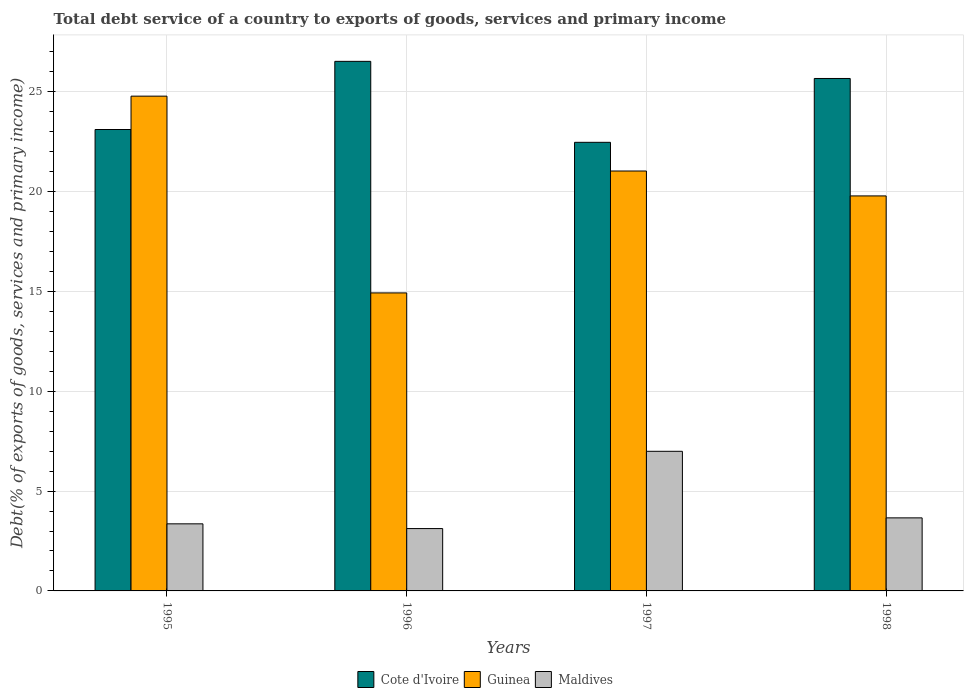In how many cases, is the number of bars for a given year not equal to the number of legend labels?
Offer a terse response. 0. What is the total debt service in Maldives in 1997?
Provide a succinct answer. 6.99. Across all years, what is the maximum total debt service in Cote d'Ivoire?
Offer a very short reply. 26.53. Across all years, what is the minimum total debt service in Cote d'Ivoire?
Keep it short and to the point. 22.47. What is the total total debt service in Cote d'Ivoire in the graph?
Keep it short and to the point. 97.78. What is the difference between the total debt service in Guinea in 1997 and that in 1998?
Provide a short and direct response. 1.25. What is the difference between the total debt service in Guinea in 1997 and the total debt service in Cote d'Ivoire in 1996?
Your response must be concise. -5.49. What is the average total debt service in Guinea per year?
Your answer should be very brief. 20.13. In the year 1998, what is the difference between the total debt service in Maldives and total debt service in Cote d'Ivoire?
Offer a very short reply. -22.01. In how many years, is the total debt service in Cote d'Ivoire greater than 26 %?
Give a very brief answer. 1. What is the ratio of the total debt service in Cote d'Ivoire in 1995 to that in 1998?
Give a very brief answer. 0.9. Is the difference between the total debt service in Maldives in 1995 and 1998 greater than the difference between the total debt service in Cote d'Ivoire in 1995 and 1998?
Your answer should be compact. Yes. What is the difference between the highest and the second highest total debt service in Cote d'Ivoire?
Keep it short and to the point. 0.86. What is the difference between the highest and the lowest total debt service in Guinea?
Ensure brevity in your answer.  9.86. What does the 1st bar from the left in 1998 represents?
Offer a very short reply. Cote d'Ivoire. What does the 3rd bar from the right in 1996 represents?
Keep it short and to the point. Cote d'Ivoire. Is it the case that in every year, the sum of the total debt service in Maldives and total debt service in Cote d'Ivoire is greater than the total debt service in Guinea?
Offer a terse response. Yes. How many bars are there?
Your response must be concise. 12. Are all the bars in the graph horizontal?
Your response must be concise. No. How many years are there in the graph?
Offer a very short reply. 4. Does the graph contain any zero values?
Provide a short and direct response. No. Where does the legend appear in the graph?
Give a very brief answer. Bottom center. How many legend labels are there?
Ensure brevity in your answer.  3. What is the title of the graph?
Keep it short and to the point. Total debt service of a country to exports of goods, services and primary income. What is the label or title of the X-axis?
Offer a terse response. Years. What is the label or title of the Y-axis?
Offer a terse response. Debt(% of exports of goods, services and primary income). What is the Debt(% of exports of goods, services and primary income) of Cote d'Ivoire in 1995?
Give a very brief answer. 23.11. What is the Debt(% of exports of goods, services and primary income) of Guinea in 1995?
Your answer should be very brief. 24.78. What is the Debt(% of exports of goods, services and primary income) in Maldives in 1995?
Ensure brevity in your answer.  3.36. What is the Debt(% of exports of goods, services and primary income) in Cote d'Ivoire in 1996?
Provide a succinct answer. 26.53. What is the Debt(% of exports of goods, services and primary income) in Guinea in 1996?
Keep it short and to the point. 14.93. What is the Debt(% of exports of goods, services and primary income) in Maldives in 1996?
Ensure brevity in your answer.  3.12. What is the Debt(% of exports of goods, services and primary income) of Cote d'Ivoire in 1997?
Your response must be concise. 22.47. What is the Debt(% of exports of goods, services and primary income) in Guinea in 1997?
Your response must be concise. 21.03. What is the Debt(% of exports of goods, services and primary income) of Maldives in 1997?
Keep it short and to the point. 6.99. What is the Debt(% of exports of goods, services and primary income) in Cote d'Ivoire in 1998?
Make the answer very short. 25.67. What is the Debt(% of exports of goods, services and primary income) in Guinea in 1998?
Your answer should be compact. 19.79. What is the Debt(% of exports of goods, services and primary income) of Maldives in 1998?
Offer a very short reply. 3.66. Across all years, what is the maximum Debt(% of exports of goods, services and primary income) of Cote d'Ivoire?
Make the answer very short. 26.53. Across all years, what is the maximum Debt(% of exports of goods, services and primary income) in Guinea?
Provide a short and direct response. 24.78. Across all years, what is the maximum Debt(% of exports of goods, services and primary income) of Maldives?
Your response must be concise. 6.99. Across all years, what is the minimum Debt(% of exports of goods, services and primary income) in Cote d'Ivoire?
Offer a very short reply. 22.47. Across all years, what is the minimum Debt(% of exports of goods, services and primary income) of Guinea?
Your answer should be very brief. 14.93. Across all years, what is the minimum Debt(% of exports of goods, services and primary income) of Maldives?
Offer a terse response. 3.12. What is the total Debt(% of exports of goods, services and primary income) in Cote d'Ivoire in the graph?
Keep it short and to the point. 97.78. What is the total Debt(% of exports of goods, services and primary income) of Guinea in the graph?
Your answer should be very brief. 80.53. What is the total Debt(% of exports of goods, services and primary income) of Maldives in the graph?
Your answer should be very brief. 17.14. What is the difference between the Debt(% of exports of goods, services and primary income) of Cote d'Ivoire in 1995 and that in 1996?
Keep it short and to the point. -3.41. What is the difference between the Debt(% of exports of goods, services and primary income) of Guinea in 1995 and that in 1996?
Provide a short and direct response. 9.86. What is the difference between the Debt(% of exports of goods, services and primary income) of Maldives in 1995 and that in 1996?
Your response must be concise. 0.24. What is the difference between the Debt(% of exports of goods, services and primary income) in Cote d'Ivoire in 1995 and that in 1997?
Provide a succinct answer. 0.64. What is the difference between the Debt(% of exports of goods, services and primary income) in Guinea in 1995 and that in 1997?
Make the answer very short. 3.75. What is the difference between the Debt(% of exports of goods, services and primary income) in Maldives in 1995 and that in 1997?
Keep it short and to the point. -3.63. What is the difference between the Debt(% of exports of goods, services and primary income) of Cote d'Ivoire in 1995 and that in 1998?
Your response must be concise. -2.56. What is the difference between the Debt(% of exports of goods, services and primary income) of Guinea in 1995 and that in 1998?
Keep it short and to the point. 5. What is the difference between the Debt(% of exports of goods, services and primary income) in Maldives in 1995 and that in 1998?
Ensure brevity in your answer.  -0.3. What is the difference between the Debt(% of exports of goods, services and primary income) in Cote d'Ivoire in 1996 and that in 1997?
Provide a short and direct response. 4.06. What is the difference between the Debt(% of exports of goods, services and primary income) in Guinea in 1996 and that in 1997?
Provide a succinct answer. -6.11. What is the difference between the Debt(% of exports of goods, services and primary income) of Maldives in 1996 and that in 1997?
Your response must be concise. -3.87. What is the difference between the Debt(% of exports of goods, services and primary income) of Cote d'Ivoire in 1996 and that in 1998?
Make the answer very short. 0.86. What is the difference between the Debt(% of exports of goods, services and primary income) of Guinea in 1996 and that in 1998?
Offer a very short reply. -4.86. What is the difference between the Debt(% of exports of goods, services and primary income) of Maldives in 1996 and that in 1998?
Provide a succinct answer. -0.54. What is the difference between the Debt(% of exports of goods, services and primary income) in Cote d'Ivoire in 1997 and that in 1998?
Offer a very short reply. -3.2. What is the difference between the Debt(% of exports of goods, services and primary income) in Guinea in 1997 and that in 1998?
Offer a terse response. 1.25. What is the difference between the Debt(% of exports of goods, services and primary income) in Maldives in 1997 and that in 1998?
Your answer should be compact. 3.33. What is the difference between the Debt(% of exports of goods, services and primary income) in Cote d'Ivoire in 1995 and the Debt(% of exports of goods, services and primary income) in Guinea in 1996?
Your response must be concise. 8.18. What is the difference between the Debt(% of exports of goods, services and primary income) of Cote d'Ivoire in 1995 and the Debt(% of exports of goods, services and primary income) of Maldives in 1996?
Offer a terse response. 19.99. What is the difference between the Debt(% of exports of goods, services and primary income) in Guinea in 1995 and the Debt(% of exports of goods, services and primary income) in Maldives in 1996?
Your answer should be very brief. 21.66. What is the difference between the Debt(% of exports of goods, services and primary income) in Cote d'Ivoire in 1995 and the Debt(% of exports of goods, services and primary income) in Guinea in 1997?
Your answer should be very brief. 2.08. What is the difference between the Debt(% of exports of goods, services and primary income) of Cote d'Ivoire in 1995 and the Debt(% of exports of goods, services and primary income) of Maldives in 1997?
Provide a short and direct response. 16.12. What is the difference between the Debt(% of exports of goods, services and primary income) in Guinea in 1995 and the Debt(% of exports of goods, services and primary income) in Maldives in 1997?
Your answer should be compact. 17.79. What is the difference between the Debt(% of exports of goods, services and primary income) in Cote d'Ivoire in 1995 and the Debt(% of exports of goods, services and primary income) in Guinea in 1998?
Your answer should be very brief. 3.33. What is the difference between the Debt(% of exports of goods, services and primary income) of Cote d'Ivoire in 1995 and the Debt(% of exports of goods, services and primary income) of Maldives in 1998?
Ensure brevity in your answer.  19.45. What is the difference between the Debt(% of exports of goods, services and primary income) of Guinea in 1995 and the Debt(% of exports of goods, services and primary income) of Maldives in 1998?
Offer a very short reply. 21.12. What is the difference between the Debt(% of exports of goods, services and primary income) of Cote d'Ivoire in 1996 and the Debt(% of exports of goods, services and primary income) of Guinea in 1997?
Offer a very short reply. 5.49. What is the difference between the Debt(% of exports of goods, services and primary income) of Cote d'Ivoire in 1996 and the Debt(% of exports of goods, services and primary income) of Maldives in 1997?
Provide a short and direct response. 19.53. What is the difference between the Debt(% of exports of goods, services and primary income) in Guinea in 1996 and the Debt(% of exports of goods, services and primary income) in Maldives in 1997?
Ensure brevity in your answer.  7.93. What is the difference between the Debt(% of exports of goods, services and primary income) of Cote d'Ivoire in 1996 and the Debt(% of exports of goods, services and primary income) of Guinea in 1998?
Provide a short and direct response. 6.74. What is the difference between the Debt(% of exports of goods, services and primary income) of Cote d'Ivoire in 1996 and the Debt(% of exports of goods, services and primary income) of Maldives in 1998?
Keep it short and to the point. 22.87. What is the difference between the Debt(% of exports of goods, services and primary income) of Guinea in 1996 and the Debt(% of exports of goods, services and primary income) of Maldives in 1998?
Give a very brief answer. 11.27. What is the difference between the Debt(% of exports of goods, services and primary income) of Cote d'Ivoire in 1997 and the Debt(% of exports of goods, services and primary income) of Guinea in 1998?
Make the answer very short. 2.69. What is the difference between the Debt(% of exports of goods, services and primary income) in Cote d'Ivoire in 1997 and the Debt(% of exports of goods, services and primary income) in Maldives in 1998?
Keep it short and to the point. 18.81. What is the difference between the Debt(% of exports of goods, services and primary income) of Guinea in 1997 and the Debt(% of exports of goods, services and primary income) of Maldives in 1998?
Your response must be concise. 17.37. What is the average Debt(% of exports of goods, services and primary income) in Cote d'Ivoire per year?
Make the answer very short. 24.44. What is the average Debt(% of exports of goods, services and primary income) of Guinea per year?
Offer a terse response. 20.13. What is the average Debt(% of exports of goods, services and primary income) of Maldives per year?
Offer a very short reply. 4.28. In the year 1995, what is the difference between the Debt(% of exports of goods, services and primary income) in Cote d'Ivoire and Debt(% of exports of goods, services and primary income) in Guinea?
Your answer should be compact. -1.67. In the year 1995, what is the difference between the Debt(% of exports of goods, services and primary income) of Cote d'Ivoire and Debt(% of exports of goods, services and primary income) of Maldives?
Keep it short and to the point. 19.75. In the year 1995, what is the difference between the Debt(% of exports of goods, services and primary income) of Guinea and Debt(% of exports of goods, services and primary income) of Maldives?
Keep it short and to the point. 21.42. In the year 1996, what is the difference between the Debt(% of exports of goods, services and primary income) of Cote d'Ivoire and Debt(% of exports of goods, services and primary income) of Guinea?
Your response must be concise. 11.6. In the year 1996, what is the difference between the Debt(% of exports of goods, services and primary income) in Cote d'Ivoire and Debt(% of exports of goods, services and primary income) in Maldives?
Make the answer very short. 23.4. In the year 1996, what is the difference between the Debt(% of exports of goods, services and primary income) of Guinea and Debt(% of exports of goods, services and primary income) of Maldives?
Your response must be concise. 11.8. In the year 1997, what is the difference between the Debt(% of exports of goods, services and primary income) in Cote d'Ivoire and Debt(% of exports of goods, services and primary income) in Guinea?
Make the answer very short. 1.44. In the year 1997, what is the difference between the Debt(% of exports of goods, services and primary income) of Cote d'Ivoire and Debt(% of exports of goods, services and primary income) of Maldives?
Your response must be concise. 15.48. In the year 1997, what is the difference between the Debt(% of exports of goods, services and primary income) in Guinea and Debt(% of exports of goods, services and primary income) in Maldives?
Provide a succinct answer. 14.04. In the year 1998, what is the difference between the Debt(% of exports of goods, services and primary income) in Cote d'Ivoire and Debt(% of exports of goods, services and primary income) in Guinea?
Make the answer very short. 5.88. In the year 1998, what is the difference between the Debt(% of exports of goods, services and primary income) of Cote d'Ivoire and Debt(% of exports of goods, services and primary income) of Maldives?
Keep it short and to the point. 22.01. In the year 1998, what is the difference between the Debt(% of exports of goods, services and primary income) of Guinea and Debt(% of exports of goods, services and primary income) of Maldives?
Keep it short and to the point. 16.13. What is the ratio of the Debt(% of exports of goods, services and primary income) in Cote d'Ivoire in 1995 to that in 1996?
Provide a succinct answer. 0.87. What is the ratio of the Debt(% of exports of goods, services and primary income) in Guinea in 1995 to that in 1996?
Make the answer very short. 1.66. What is the ratio of the Debt(% of exports of goods, services and primary income) of Maldives in 1995 to that in 1996?
Your answer should be compact. 1.08. What is the ratio of the Debt(% of exports of goods, services and primary income) of Cote d'Ivoire in 1995 to that in 1997?
Give a very brief answer. 1.03. What is the ratio of the Debt(% of exports of goods, services and primary income) in Guinea in 1995 to that in 1997?
Offer a very short reply. 1.18. What is the ratio of the Debt(% of exports of goods, services and primary income) in Maldives in 1995 to that in 1997?
Make the answer very short. 0.48. What is the ratio of the Debt(% of exports of goods, services and primary income) of Cote d'Ivoire in 1995 to that in 1998?
Give a very brief answer. 0.9. What is the ratio of the Debt(% of exports of goods, services and primary income) of Guinea in 1995 to that in 1998?
Your answer should be very brief. 1.25. What is the ratio of the Debt(% of exports of goods, services and primary income) of Maldives in 1995 to that in 1998?
Keep it short and to the point. 0.92. What is the ratio of the Debt(% of exports of goods, services and primary income) in Cote d'Ivoire in 1996 to that in 1997?
Provide a succinct answer. 1.18. What is the ratio of the Debt(% of exports of goods, services and primary income) of Guinea in 1996 to that in 1997?
Your response must be concise. 0.71. What is the ratio of the Debt(% of exports of goods, services and primary income) of Maldives in 1996 to that in 1997?
Your answer should be compact. 0.45. What is the ratio of the Debt(% of exports of goods, services and primary income) in Cote d'Ivoire in 1996 to that in 1998?
Your answer should be very brief. 1.03. What is the ratio of the Debt(% of exports of goods, services and primary income) in Guinea in 1996 to that in 1998?
Make the answer very short. 0.75. What is the ratio of the Debt(% of exports of goods, services and primary income) in Maldives in 1996 to that in 1998?
Provide a short and direct response. 0.85. What is the ratio of the Debt(% of exports of goods, services and primary income) of Cote d'Ivoire in 1997 to that in 1998?
Your response must be concise. 0.88. What is the ratio of the Debt(% of exports of goods, services and primary income) in Guinea in 1997 to that in 1998?
Provide a succinct answer. 1.06. What is the ratio of the Debt(% of exports of goods, services and primary income) of Maldives in 1997 to that in 1998?
Ensure brevity in your answer.  1.91. What is the difference between the highest and the second highest Debt(% of exports of goods, services and primary income) of Cote d'Ivoire?
Your answer should be compact. 0.86. What is the difference between the highest and the second highest Debt(% of exports of goods, services and primary income) in Guinea?
Provide a succinct answer. 3.75. What is the difference between the highest and the second highest Debt(% of exports of goods, services and primary income) in Maldives?
Your response must be concise. 3.33. What is the difference between the highest and the lowest Debt(% of exports of goods, services and primary income) in Cote d'Ivoire?
Provide a short and direct response. 4.06. What is the difference between the highest and the lowest Debt(% of exports of goods, services and primary income) of Guinea?
Ensure brevity in your answer.  9.86. What is the difference between the highest and the lowest Debt(% of exports of goods, services and primary income) of Maldives?
Offer a very short reply. 3.87. 